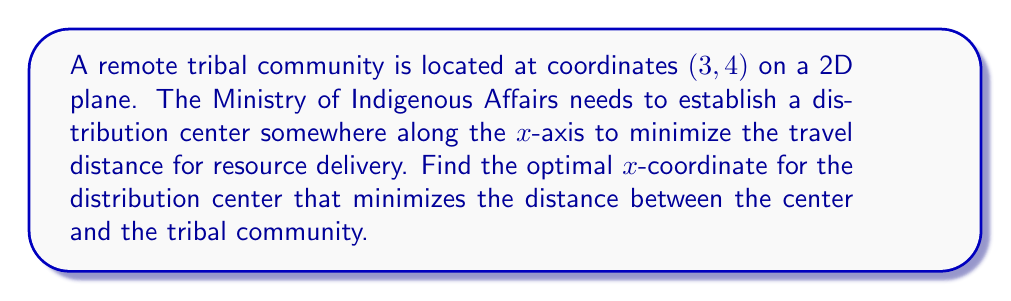Provide a solution to this math problem. To solve this problem, we'll use the distance formula and calculus to minimize the distance function.

Step 1: Define the distance function
Let $(x, 0)$ be the coordinates of the distribution center on the x-axis.
The distance function is:
$$d(x) = \sqrt{(x-3)^2 + (0-4)^2} = \sqrt{(x-3)^2 + 16}$$

Step 2: To minimize the distance, we need to find where the derivative of $d(x)$ equals zero.
$$\frac{d}{dx}d(x) = \frac{d}{dx}\sqrt{(x-3)^2 + 16}$$

Step 3: Use the chain rule to differentiate
$$\frac{d}{dx}d(x) = \frac{1}{2\sqrt{(x-3)^2 + 16}} \cdot \frac{d}{dx}((x-3)^2 + 16)$$
$$= \frac{1}{2\sqrt{(x-3)^2 + 16}} \cdot 2(x-3)$$
$$= \frac{x-3}{\sqrt{(x-3)^2 + 16}}$$

Step 4: Set the derivative equal to zero and solve
$$\frac{x-3}{\sqrt{(x-3)^2 + 16}} = 0$$

The numerator must be zero for this equation to be true:
$$x-3 = 0$$
$$x = 3$$

Step 5: Verify this is a minimum by checking the second derivative (which is positive at x = 3, confirming a minimum).

Therefore, the optimal x-coordinate for the distribution center is x = 3.
Answer: $x = 3$ 